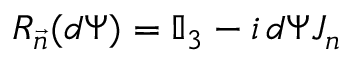<formula> <loc_0><loc_0><loc_500><loc_500>R _ { \vec { n } } ( d \Psi ) = \mathbb { I } _ { 3 } - i \, d \Psi J _ { n }</formula> 